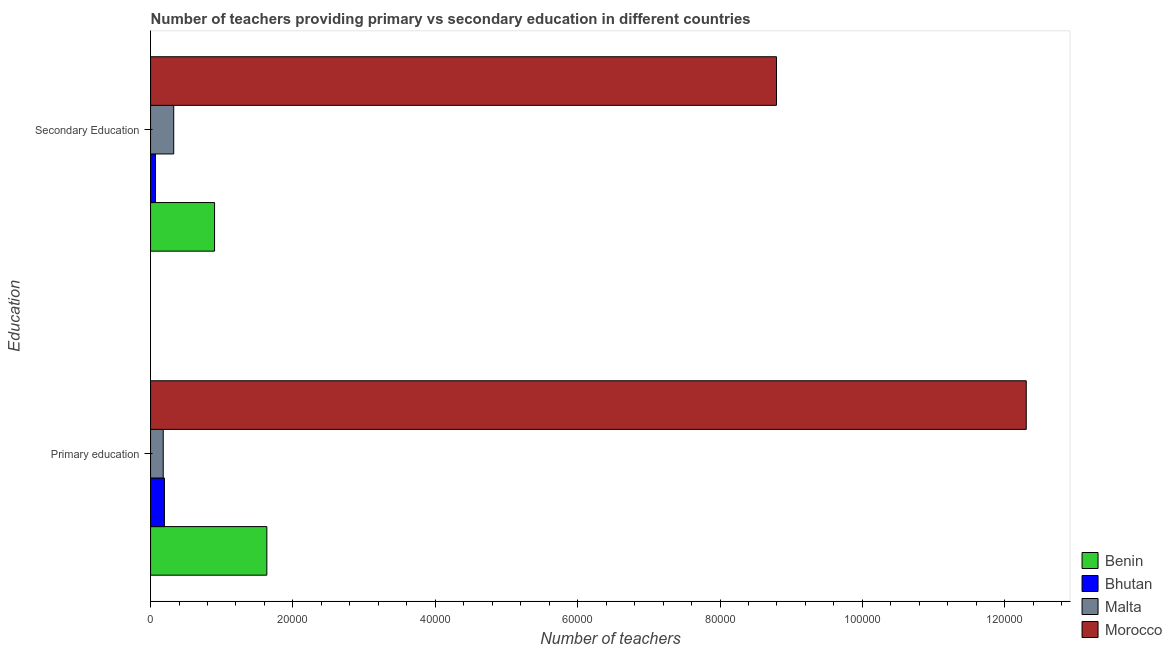How many different coloured bars are there?
Offer a very short reply. 4. Are the number of bars per tick equal to the number of legend labels?
Offer a terse response. Yes. Are the number of bars on each tick of the Y-axis equal?
Provide a short and direct response. Yes. How many bars are there on the 1st tick from the bottom?
Your answer should be very brief. 4. What is the label of the 1st group of bars from the top?
Your response must be concise. Secondary Education. What is the number of secondary teachers in Morocco?
Your answer should be compact. 8.79e+04. Across all countries, what is the maximum number of primary teachers?
Your answer should be compact. 1.23e+05. Across all countries, what is the minimum number of secondary teachers?
Offer a very short reply. 692. In which country was the number of primary teachers maximum?
Provide a succinct answer. Morocco. In which country was the number of primary teachers minimum?
Your answer should be very brief. Malta. What is the total number of secondary teachers in the graph?
Your answer should be compact. 1.01e+05. What is the difference between the number of primary teachers in Bhutan and that in Morocco?
Keep it short and to the point. -1.21e+05. What is the difference between the number of primary teachers in Benin and the number of secondary teachers in Bhutan?
Provide a short and direct response. 1.56e+04. What is the average number of primary teachers per country?
Provide a succinct answer. 3.58e+04. What is the difference between the number of secondary teachers and number of primary teachers in Bhutan?
Offer a very short reply. -1254. In how many countries, is the number of primary teachers greater than 4000 ?
Offer a terse response. 2. What is the ratio of the number of secondary teachers in Benin to that in Malta?
Offer a terse response. 2.76. Is the number of secondary teachers in Morocco less than that in Bhutan?
Provide a succinct answer. No. What does the 2nd bar from the top in Secondary Education represents?
Ensure brevity in your answer.  Malta. What does the 1st bar from the bottom in Primary education represents?
Provide a succinct answer. Benin. How many countries are there in the graph?
Make the answer very short. 4. Does the graph contain grids?
Offer a terse response. No. Where does the legend appear in the graph?
Provide a succinct answer. Bottom right. How are the legend labels stacked?
Make the answer very short. Vertical. What is the title of the graph?
Ensure brevity in your answer.  Number of teachers providing primary vs secondary education in different countries. What is the label or title of the X-axis?
Ensure brevity in your answer.  Number of teachers. What is the label or title of the Y-axis?
Provide a short and direct response. Education. What is the Number of teachers of Benin in Primary education?
Your answer should be compact. 1.63e+04. What is the Number of teachers in Bhutan in Primary education?
Provide a short and direct response. 1946. What is the Number of teachers in Malta in Primary education?
Keep it short and to the point. 1779. What is the Number of teachers of Morocco in Primary education?
Offer a terse response. 1.23e+05. What is the Number of teachers in Benin in Secondary Education?
Provide a short and direct response. 8988. What is the Number of teachers in Bhutan in Secondary Education?
Provide a short and direct response. 692. What is the Number of teachers of Malta in Secondary Education?
Give a very brief answer. 3253. What is the Number of teachers in Morocco in Secondary Education?
Keep it short and to the point. 8.79e+04. Across all Education, what is the maximum Number of teachers in Benin?
Your answer should be very brief. 1.63e+04. Across all Education, what is the maximum Number of teachers in Bhutan?
Your answer should be very brief. 1946. Across all Education, what is the maximum Number of teachers of Malta?
Your response must be concise. 3253. Across all Education, what is the maximum Number of teachers of Morocco?
Offer a very short reply. 1.23e+05. Across all Education, what is the minimum Number of teachers of Benin?
Provide a short and direct response. 8988. Across all Education, what is the minimum Number of teachers of Bhutan?
Ensure brevity in your answer.  692. Across all Education, what is the minimum Number of teachers of Malta?
Offer a very short reply. 1779. Across all Education, what is the minimum Number of teachers in Morocco?
Give a very brief answer. 8.79e+04. What is the total Number of teachers in Benin in the graph?
Your answer should be very brief. 2.53e+04. What is the total Number of teachers in Bhutan in the graph?
Keep it short and to the point. 2638. What is the total Number of teachers in Malta in the graph?
Keep it short and to the point. 5032. What is the total Number of teachers in Morocco in the graph?
Offer a very short reply. 2.11e+05. What is the difference between the Number of teachers of Benin in Primary education and that in Secondary Education?
Give a very brief answer. 7347. What is the difference between the Number of teachers in Bhutan in Primary education and that in Secondary Education?
Make the answer very short. 1254. What is the difference between the Number of teachers of Malta in Primary education and that in Secondary Education?
Provide a succinct answer. -1474. What is the difference between the Number of teachers of Morocco in Primary education and that in Secondary Education?
Keep it short and to the point. 3.51e+04. What is the difference between the Number of teachers of Benin in Primary education and the Number of teachers of Bhutan in Secondary Education?
Give a very brief answer. 1.56e+04. What is the difference between the Number of teachers in Benin in Primary education and the Number of teachers in Malta in Secondary Education?
Offer a very short reply. 1.31e+04. What is the difference between the Number of teachers of Benin in Primary education and the Number of teachers of Morocco in Secondary Education?
Keep it short and to the point. -7.16e+04. What is the difference between the Number of teachers of Bhutan in Primary education and the Number of teachers of Malta in Secondary Education?
Give a very brief answer. -1307. What is the difference between the Number of teachers of Bhutan in Primary education and the Number of teachers of Morocco in Secondary Education?
Keep it short and to the point. -8.60e+04. What is the difference between the Number of teachers in Malta in Primary education and the Number of teachers in Morocco in Secondary Education?
Your answer should be compact. -8.62e+04. What is the average Number of teachers in Benin per Education?
Your response must be concise. 1.27e+04. What is the average Number of teachers in Bhutan per Education?
Keep it short and to the point. 1319. What is the average Number of teachers of Malta per Education?
Make the answer very short. 2516. What is the average Number of teachers in Morocco per Education?
Your response must be concise. 1.05e+05. What is the difference between the Number of teachers of Benin and Number of teachers of Bhutan in Primary education?
Your answer should be compact. 1.44e+04. What is the difference between the Number of teachers of Benin and Number of teachers of Malta in Primary education?
Provide a succinct answer. 1.46e+04. What is the difference between the Number of teachers of Benin and Number of teachers of Morocco in Primary education?
Ensure brevity in your answer.  -1.07e+05. What is the difference between the Number of teachers of Bhutan and Number of teachers of Malta in Primary education?
Provide a succinct answer. 167. What is the difference between the Number of teachers of Bhutan and Number of teachers of Morocco in Primary education?
Offer a very short reply. -1.21e+05. What is the difference between the Number of teachers in Malta and Number of teachers in Morocco in Primary education?
Your response must be concise. -1.21e+05. What is the difference between the Number of teachers in Benin and Number of teachers in Bhutan in Secondary Education?
Offer a very short reply. 8296. What is the difference between the Number of teachers in Benin and Number of teachers in Malta in Secondary Education?
Give a very brief answer. 5735. What is the difference between the Number of teachers of Benin and Number of teachers of Morocco in Secondary Education?
Give a very brief answer. -7.89e+04. What is the difference between the Number of teachers in Bhutan and Number of teachers in Malta in Secondary Education?
Offer a terse response. -2561. What is the difference between the Number of teachers in Bhutan and Number of teachers in Morocco in Secondary Education?
Offer a terse response. -8.72e+04. What is the difference between the Number of teachers in Malta and Number of teachers in Morocco in Secondary Education?
Your answer should be very brief. -8.47e+04. What is the ratio of the Number of teachers of Benin in Primary education to that in Secondary Education?
Provide a succinct answer. 1.82. What is the ratio of the Number of teachers in Bhutan in Primary education to that in Secondary Education?
Make the answer very short. 2.81. What is the ratio of the Number of teachers of Malta in Primary education to that in Secondary Education?
Provide a short and direct response. 0.55. What is the ratio of the Number of teachers of Morocco in Primary education to that in Secondary Education?
Provide a short and direct response. 1.4. What is the difference between the highest and the second highest Number of teachers of Benin?
Your answer should be compact. 7347. What is the difference between the highest and the second highest Number of teachers in Bhutan?
Ensure brevity in your answer.  1254. What is the difference between the highest and the second highest Number of teachers of Malta?
Give a very brief answer. 1474. What is the difference between the highest and the second highest Number of teachers of Morocco?
Offer a very short reply. 3.51e+04. What is the difference between the highest and the lowest Number of teachers of Benin?
Provide a succinct answer. 7347. What is the difference between the highest and the lowest Number of teachers in Bhutan?
Make the answer very short. 1254. What is the difference between the highest and the lowest Number of teachers of Malta?
Ensure brevity in your answer.  1474. What is the difference between the highest and the lowest Number of teachers in Morocco?
Ensure brevity in your answer.  3.51e+04. 